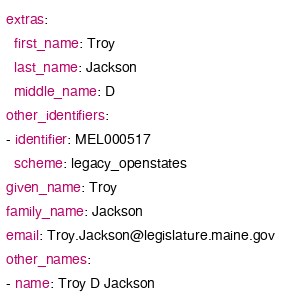Convert code to text. <code><loc_0><loc_0><loc_500><loc_500><_YAML_>extras:
  first_name: Troy
  last_name: Jackson
  middle_name: D
other_identifiers:
- identifier: MEL000517
  scheme: legacy_openstates
given_name: Troy
family_name: Jackson
email: Troy.Jackson@legislature.maine.gov
other_names:
- name: Troy D Jackson
</code> 